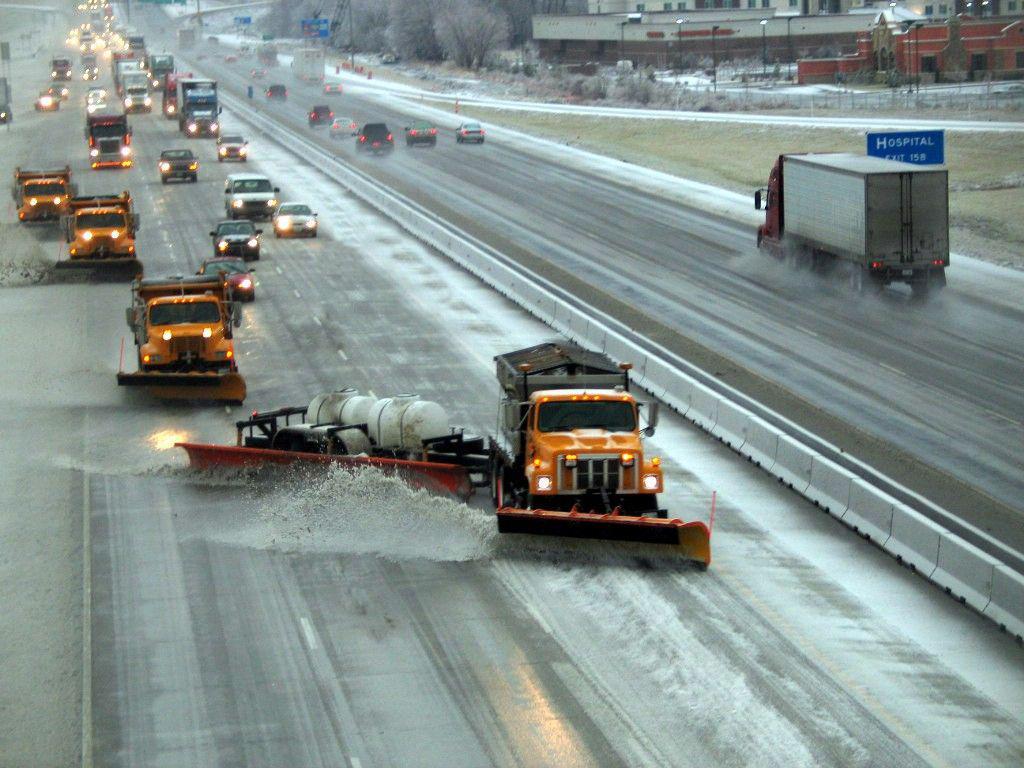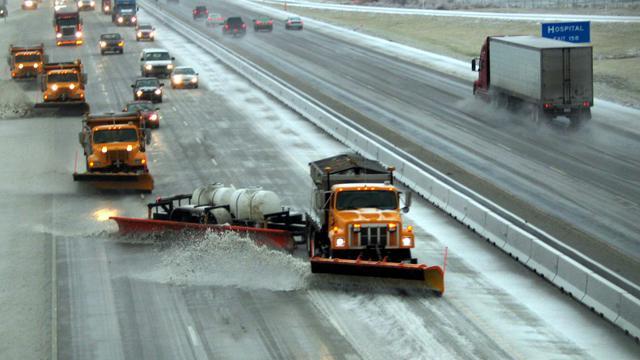The first image is the image on the left, the second image is the image on the right. Considering the images on both sides, is "At least one of the images shows a highway scene." valid? Answer yes or no. Yes. 